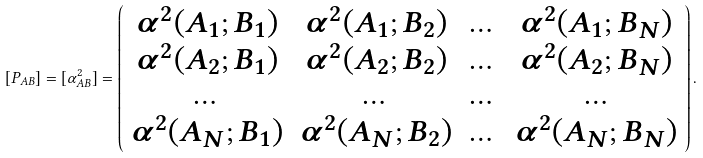<formula> <loc_0><loc_0><loc_500><loc_500>\left [ P _ { A B } \right ] = [ \alpha _ { A B } ^ { 2 } ] = \left ( \begin{array} { c c c c } \alpha ^ { 2 } ( A _ { 1 } ; B _ { 1 } ) & \alpha ^ { 2 } ( A _ { 1 } ; B _ { 2 } ) & \dots & \alpha ^ { 2 } ( A _ { 1 } ; B _ { N } ) \\ \alpha ^ { 2 } ( A _ { 2 } ; B _ { 1 } ) & \alpha ^ { 2 } ( A _ { 2 } ; B _ { 2 } ) & \dots & \alpha ^ { 2 } ( A _ { 2 } ; B _ { N } ) \\ \dots & \dots & \dots & \dots \\ \alpha ^ { 2 } ( A _ { N } ; B _ { 1 } ) & \alpha ^ { 2 } ( A _ { N } ; B _ { 2 } ) & \dots & \alpha ^ { 2 } ( A _ { N } ; B _ { N } ) \end{array} \right ) .</formula> 